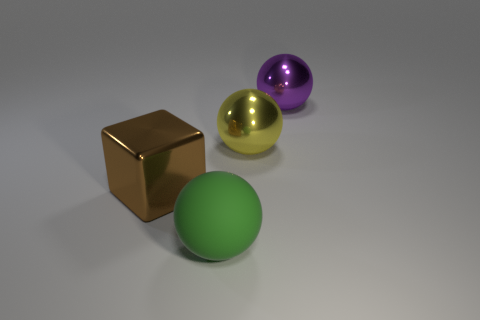Are there any objects made of the same material as the purple ball?
Ensure brevity in your answer.  Yes. What size is the purple metallic object on the right side of the large yellow metallic thing?
Keep it short and to the point. Large. There is a object that is in front of the metallic block; are there any large brown metal blocks that are to the left of it?
Provide a short and direct response. Yes. Is the size of the rubber ball the same as the sphere that is on the right side of the big yellow sphere?
Keep it short and to the point. Yes. Are there any large things on the left side of the big thing right of the large metallic ball on the left side of the large purple shiny object?
Offer a terse response. Yes. There is a green ball that is in front of the yellow sphere; what material is it?
Offer a very short reply. Rubber. Do the green ball and the metal block have the same size?
Your response must be concise. Yes. The object that is both right of the big brown shiny cube and on the left side of the large yellow metal ball is what color?
Your response must be concise. Green. What is the shape of the large purple thing that is the same material as the big brown cube?
Offer a very short reply. Sphere. How many big metal objects are right of the large yellow shiny sphere and on the left side of the yellow metal sphere?
Ensure brevity in your answer.  0. 